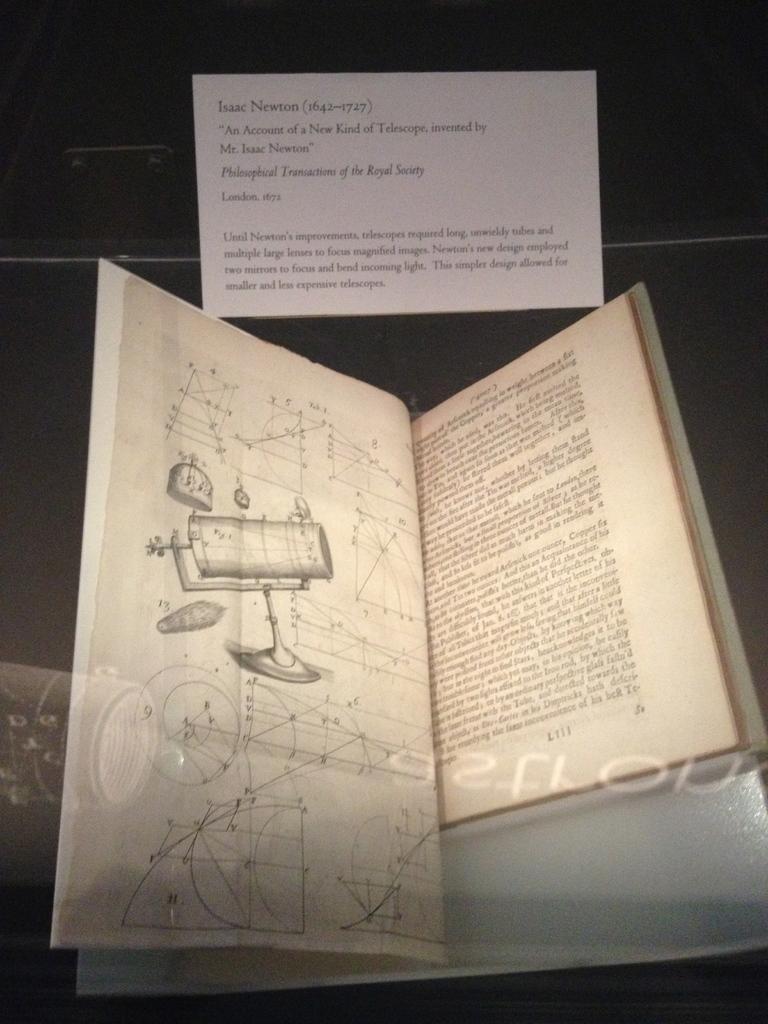Could you give a brief overview of what you see in this image? In this image there is a book with some pictures and text on it. Above the book there is a note with some text. 